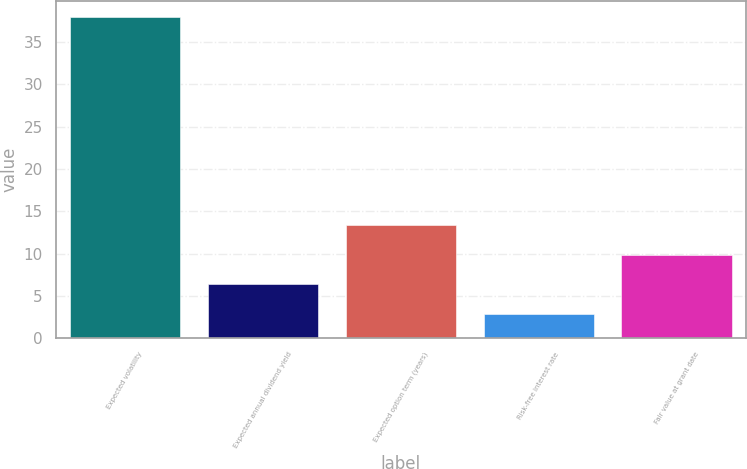Convert chart. <chart><loc_0><loc_0><loc_500><loc_500><bar_chart><fcel>Expected volatility<fcel>Expected annual dividend yield<fcel>Expected option term (years)<fcel>Risk-free interest rate<fcel>Fair value at grant date<nl><fcel>38<fcel>6.37<fcel>13.39<fcel>2.86<fcel>9.88<nl></chart> 